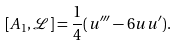<formula> <loc_0><loc_0><loc_500><loc_500>[ A _ { 1 } , \mathcal { L } ] = \frac { 1 } { 4 } ( u ^ { \prime \prime \prime } - 6 u u ^ { \prime } ) .</formula> 